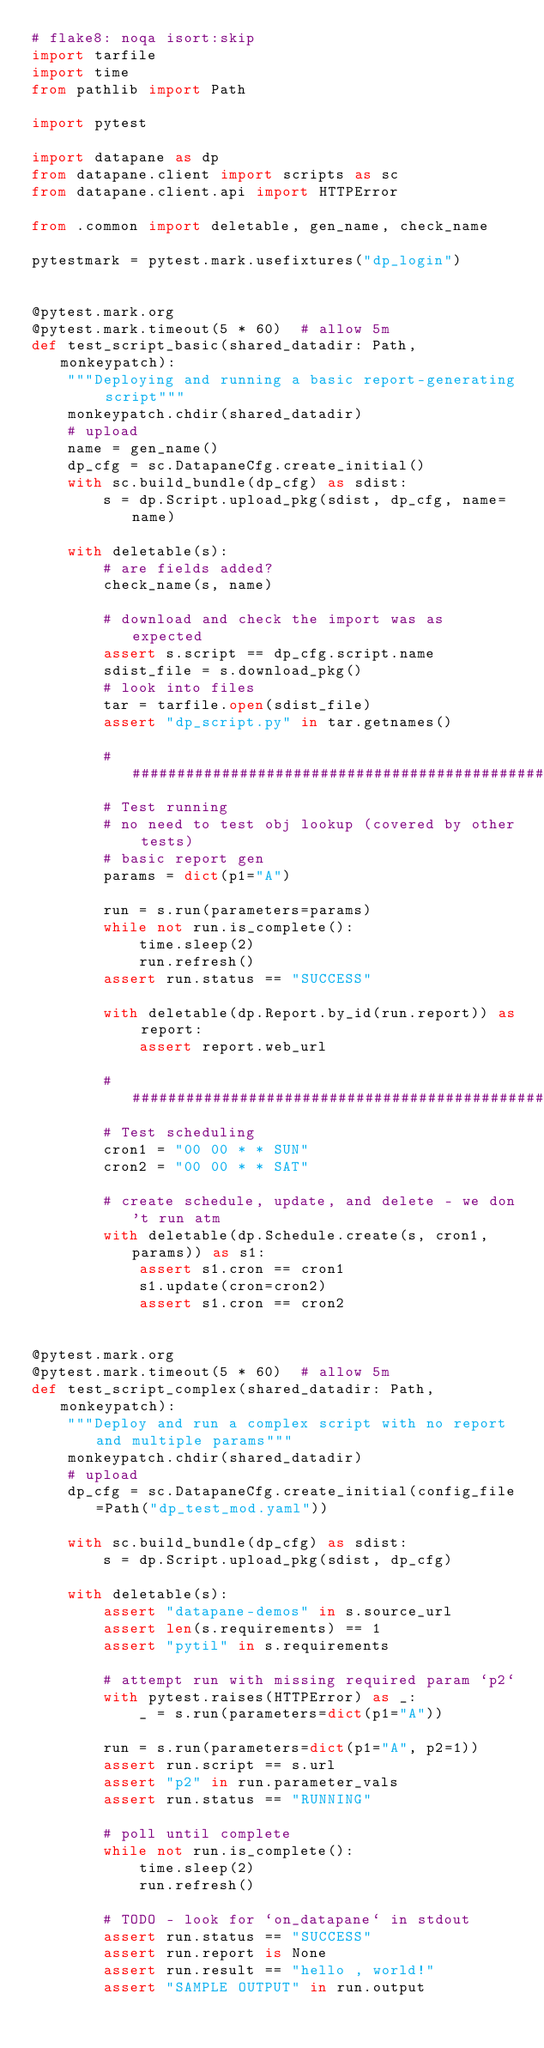<code> <loc_0><loc_0><loc_500><loc_500><_Python_># flake8: noqa isort:skip
import tarfile
import time
from pathlib import Path

import pytest

import datapane as dp
from datapane.client import scripts as sc
from datapane.client.api import HTTPError

from .common import deletable, gen_name, check_name

pytestmark = pytest.mark.usefixtures("dp_login")


@pytest.mark.org
@pytest.mark.timeout(5 * 60)  # allow 5m
def test_script_basic(shared_datadir: Path, monkeypatch):
    """Deploying and running a basic report-generating script"""
    monkeypatch.chdir(shared_datadir)
    # upload
    name = gen_name()
    dp_cfg = sc.DatapaneCfg.create_initial()
    with sc.build_bundle(dp_cfg) as sdist:
        s = dp.Script.upload_pkg(sdist, dp_cfg, name=name)

    with deletable(s):
        # are fields added?
        check_name(s, name)

        # download and check the import was as expected
        assert s.script == dp_cfg.script.name
        sdist_file = s.download_pkg()
        # look into files
        tar = tarfile.open(sdist_file)
        assert "dp_script.py" in tar.getnames()

        ########################################################################
        # Test running
        # no need to test obj lookup (covered by other tests)
        # basic report gen
        params = dict(p1="A")

        run = s.run(parameters=params)
        while not run.is_complete():
            time.sleep(2)
            run.refresh()
        assert run.status == "SUCCESS"

        with deletable(dp.Report.by_id(run.report)) as report:
            assert report.web_url

        ########################################################################
        # Test scheduling
        cron1 = "00 00 * * SUN"
        cron2 = "00 00 * * SAT"

        # create schedule, update, and delete - we don't run atm
        with deletable(dp.Schedule.create(s, cron1, params)) as s1:
            assert s1.cron == cron1
            s1.update(cron=cron2)
            assert s1.cron == cron2


@pytest.mark.org
@pytest.mark.timeout(5 * 60)  # allow 5m
def test_script_complex(shared_datadir: Path, monkeypatch):
    """Deploy and run a complex script with no report and multiple params"""
    monkeypatch.chdir(shared_datadir)
    # upload
    dp_cfg = sc.DatapaneCfg.create_initial(config_file=Path("dp_test_mod.yaml"))

    with sc.build_bundle(dp_cfg) as sdist:
        s = dp.Script.upload_pkg(sdist, dp_cfg)

    with deletable(s):
        assert "datapane-demos" in s.source_url
        assert len(s.requirements) == 1
        assert "pytil" in s.requirements

        # attempt run with missing required param `p2`
        with pytest.raises(HTTPError) as _:
            _ = s.run(parameters=dict(p1="A"))

        run = s.run(parameters=dict(p1="A", p2=1))
        assert run.script == s.url
        assert "p2" in run.parameter_vals
        assert run.status == "RUNNING"

        # poll until complete
        while not run.is_complete():
            time.sleep(2)
            run.refresh()

        # TODO - look for `on_datapane` in stdout
        assert run.status == "SUCCESS"
        assert run.report is None
        assert run.result == "hello , world!"
        assert "SAMPLE OUTPUT" in run.output

</code> 